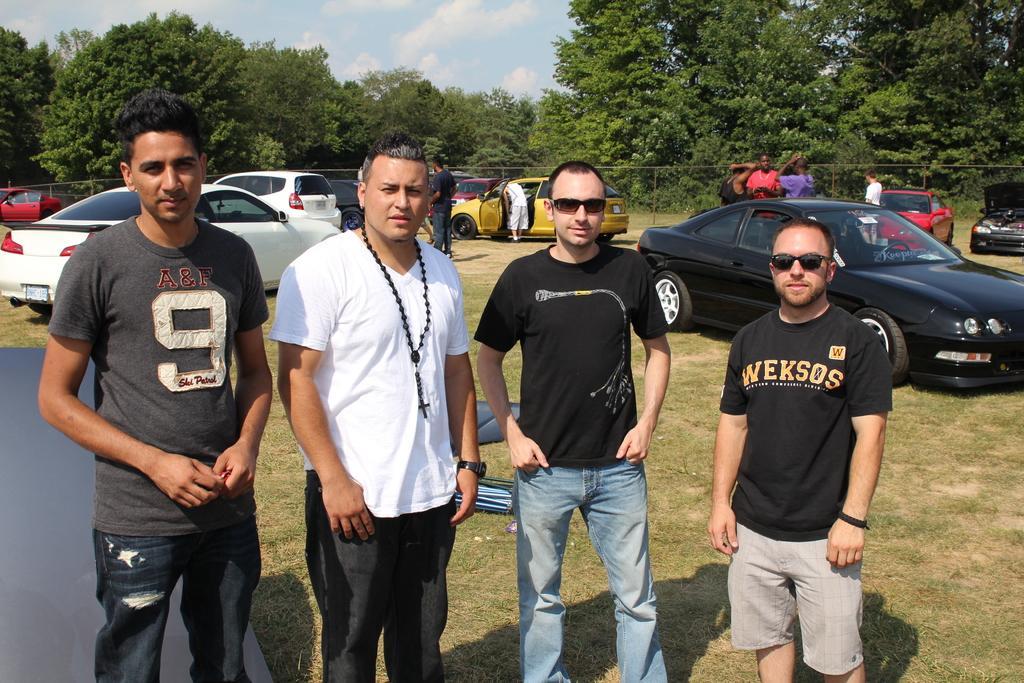Please provide a concise description of this image. In this picture I can see there are four people standing here and there wearing t-shirts and in the backdrop there are few cars and few other people standing here and there are trees and sky is clear. 